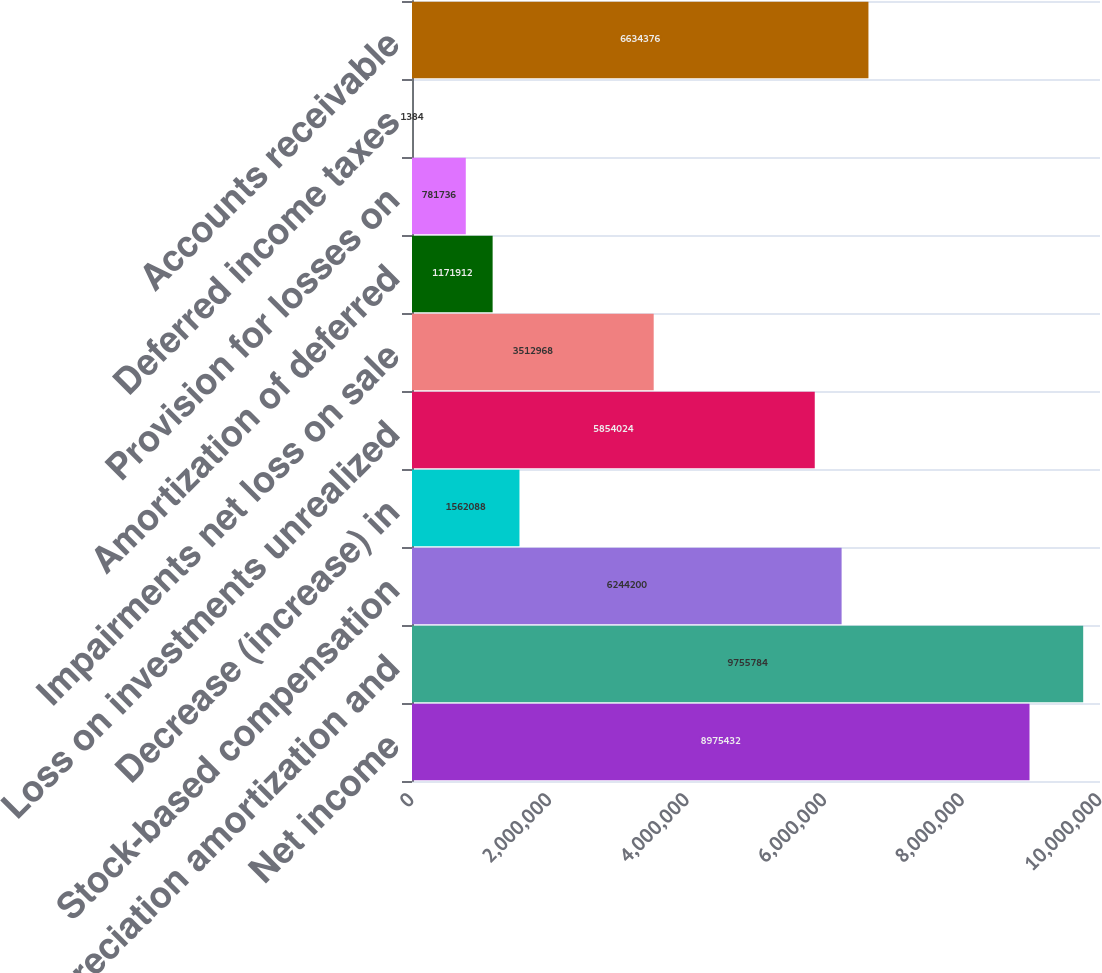Convert chart to OTSL. <chart><loc_0><loc_0><loc_500><loc_500><bar_chart><fcel>Net income<fcel>Depreciation amortization and<fcel>Stock-based compensation<fcel>Decrease (increase) in<fcel>Loss on investments unrealized<fcel>Impairments net loss on sale<fcel>Amortization of deferred<fcel>Provision for losses on<fcel>Deferred income taxes<fcel>Accounts receivable<nl><fcel>8.97543e+06<fcel>9.75578e+06<fcel>6.2442e+06<fcel>1.56209e+06<fcel>5.85402e+06<fcel>3.51297e+06<fcel>1.17191e+06<fcel>781736<fcel>1384<fcel>6.63438e+06<nl></chart> 